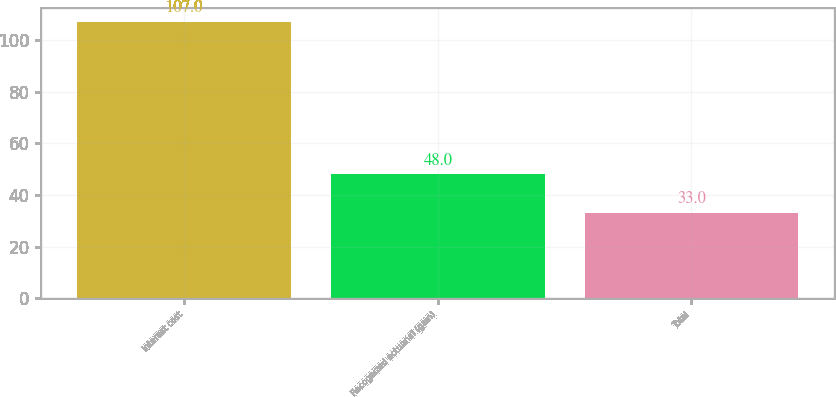Convert chart. <chart><loc_0><loc_0><loc_500><loc_500><bar_chart><fcel>Interest cost<fcel>Recognized actuarial (gain)<fcel>Total<nl><fcel>107<fcel>48<fcel>33<nl></chart> 